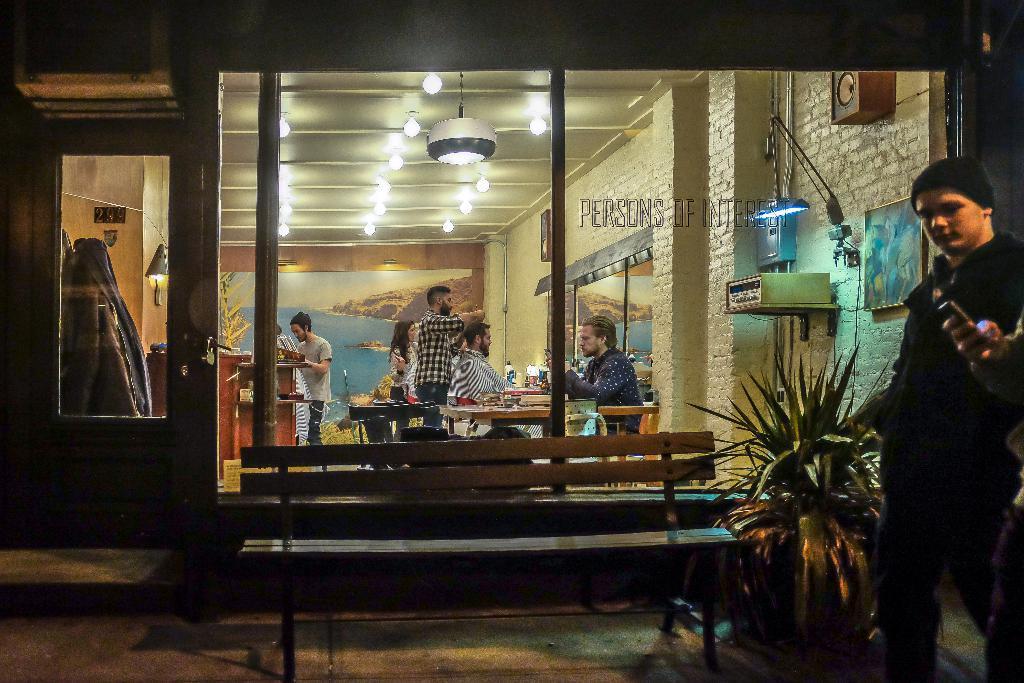Please provide a concise description of this image. On the right side of the image there is a person holding a mobile in his hand, beside him there is another person, behind him there is a plant, beside the plant there is a bench, behind the bench there is a glass wall and a wooden door with glass, through the glass wall we can see there is a person sitting on the chair, in front of the person on the table there are some objects, beside him there is another person standing and doing an hair cut to the person in front of him, in front of them there are some objects, in front of the objects there is a mirror and a photo frame on the wall, behind him there is a woman and a person standing, in front of the person there are some objects on the counter. On top of the image there are lamps on the roof, on the left side of the image there are coats hangs on to the hanger, behind the plant there are photo frame and some other objects on the wall and there is some text written on the glass. 